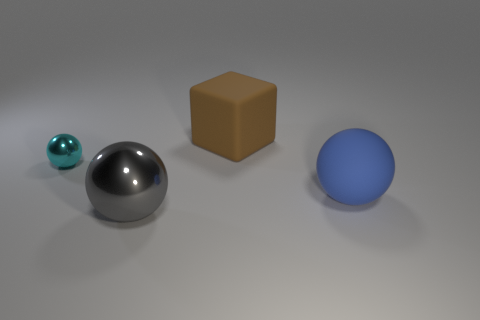Add 4 tiny purple things. How many objects exist? 8 Subtract all cubes. How many objects are left? 3 Subtract 0 brown spheres. How many objects are left? 4 Subtract all big gray metal spheres. Subtract all cyan things. How many objects are left? 2 Add 1 small spheres. How many small spheres are left? 2 Add 2 large rubber things. How many large rubber things exist? 4 